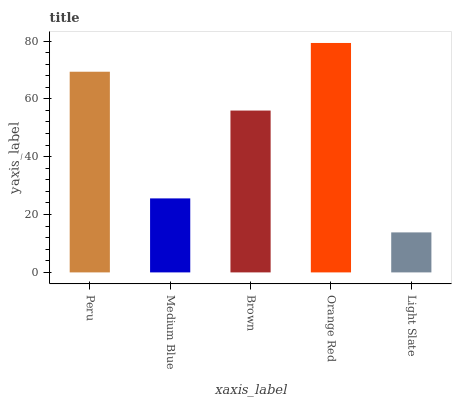Is Light Slate the minimum?
Answer yes or no. Yes. Is Orange Red the maximum?
Answer yes or no. Yes. Is Medium Blue the minimum?
Answer yes or no. No. Is Medium Blue the maximum?
Answer yes or no. No. Is Peru greater than Medium Blue?
Answer yes or no. Yes. Is Medium Blue less than Peru?
Answer yes or no. Yes. Is Medium Blue greater than Peru?
Answer yes or no. No. Is Peru less than Medium Blue?
Answer yes or no. No. Is Brown the high median?
Answer yes or no. Yes. Is Brown the low median?
Answer yes or no. Yes. Is Orange Red the high median?
Answer yes or no. No. Is Peru the low median?
Answer yes or no. No. 